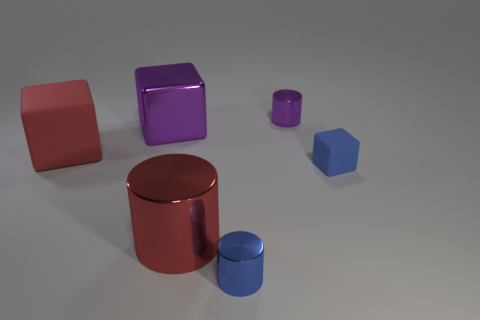Is the number of large red rubber objects to the left of the red shiny cylinder greater than the number of large green matte things?
Your response must be concise. Yes. How many other objects are there of the same material as the blue cube?
Provide a short and direct response. 1. How many big things are either red shiny objects or cyan matte balls?
Provide a short and direct response. 1. Is the material of the large red block the same as the big red cylinder?
Give a very brief answer. No. There is a tiny cylinder that is in front of the blue cube; how many small metal cylinders are behind it?
Provide a succinct answer. 1. Are there any big red rubber objects of the same shape as the big purple thing?
Give a very brief answer. Yes. There is a big metallic object that is in front of the tiny cube; does it have the same shape as the rubber thing behind the small blue block?
Your response must be concise. No. The thing that is both right of the big purple shiny thing and behind the small blue rubber object has what shape?
Offer a terse response. Cylinder. Are there any cubes that have the same size as the blue metallic object?
Provide a succinct answer. Yes. Does the metal block have the same color as the tiny shiny cylinder that is behind the small blue block?
Give a very brief answer. Yes. 